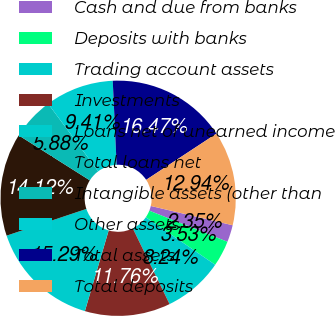<chart> <loc_0><loc_0><loc_500><loc_500><pie_chart><fcel>Cash and due from banks<fcel>Deposits with banks<fcel>Trading account assets<fcel>Investments<fcel>Loans net of unearned income<fcel>Total loans net<fcel>Intangible assets (other than<fcel>Other assets<fcel>Total assets<fcel>Total deposits<nl><fcel>2.35%<fcel>3.53%<fcel>8.24%<fcel>11.76%<fcel>15.29%<fcel>14.12%<fcel>5.88%<fcel>9.41%<fcel>16.47%<fcel>12.94%<nl></chart> 